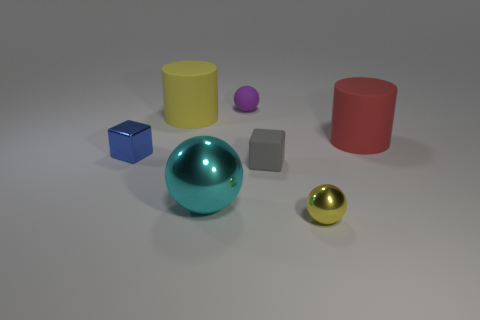Add 2 small red rubber balls. How many objects exist? 9 Subtract all cylinders. How many objects are left? 5 Add 2 big yellow rubber objects. How many big yellow rubber objects are left? 3 Add 6 yellow rubber objects. How many yellow rubber objects exist? 7 Subtract 0 blue spheres. How many objects are left? 7 Subtract all rubber objects. Subtract all big yellow matte cylinders. How many objects are left? 2 